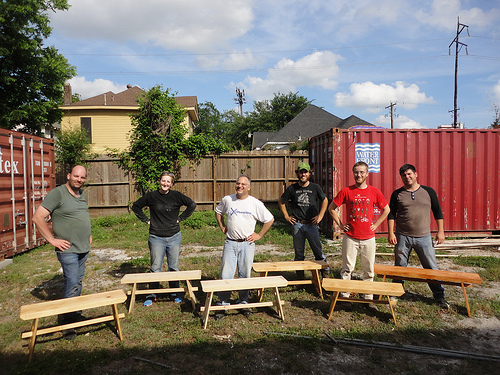<image>
Can you confirm if the man is on the bench? No. The man is not positioned on the bench. They may be near each other, but the man is not supported by or resting on top of the bench. Is the white man to the right of the red man? Yes. From this viewpoint, the white man is positioned to the right side relative to the red man. 